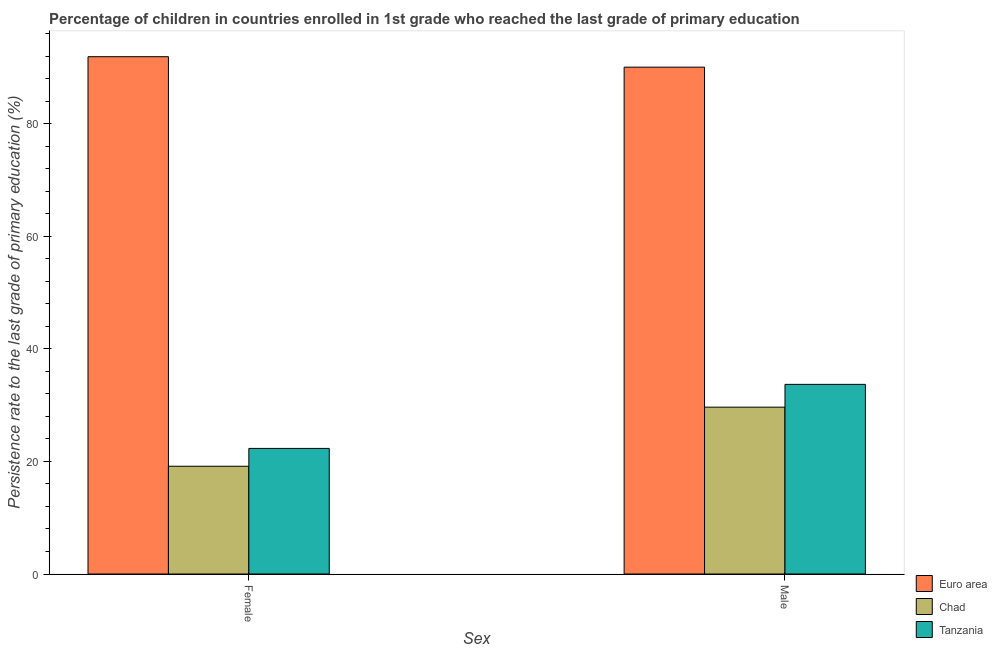How many different coloured bars are there?
Provide a succinct answer. 3. How many groups of bars are there?
Provide a short and direct response. 2. Are the number of bars per tick equal to the number of legend labels?
Offer a very short reply. Yes. Are the number of bars on each tick of the X-axis equal?
Give a very brief answer. Yes. How many bars are there on the 2nd tick from the left?
Offer a very short reply. 3. What is the label of the 1st group of bars from the left?
Ensure brevity in your answer.  Female. What is the persistence rate of female students in Chad?
Provide a short and direct response. 19.15. Across all countries, what is the maximum persistence rate of male students?
Your answer should be compact. 90.04. Across all countries, what is the minimum persistence rate of female students?
Your response must be concise. 19.15. In which country was the persistence rate of male students minimum?
Keep it short and to the point. Chad. What is the total persistence rate of female students in the graph?
Your response must be concise. 133.36. What is the difference between the persistence rate of female students in Chad and that in Euro area?
Your answer should be very brief. -72.76. What is the difference between the persistence rate of female students in Euro area and the persistence rate of male students in Tanzania?
Keep it short and to the point. 58.21. What is the average persistence rate of male students per country?
Your answer should be very brief. 51.12. What is the difference between the persistence rate of female students and persistence rate of male students in Chad?
Give a very brief answer. -10.49. In how many countries, is the persistence rate of male students greater than 44 %?
Provide a succinct answer. 1. What is the ratio of the persistence rate of female students in Euro area to that in Chad?
Your response must be concise. 4.8. What does the 2nd bar from the left in Female represents?
Make the answer very short. Chad. What does the 1st bar from the right in Female represents?
Provide a succinct answer. Tanzania. How many bars are there?
Ensure brevity in your answer.  6. Are all the bars in the graph horizontal?
Your answer should be very brief. No. How many countries are there in the graph?
Provide a succinct answer. 3. Does the graph contain any zero values?
Offer a very short reply. No. Does the graph contain grids?
Provide a succinct answer. No. How are the legend labels stacked?
Keep it short and to the point. Vertical. What is the title of the graph?
Offer a terse response. Percentage of children in countries enrolled in 1st grade who reached the last grade of primary education. Does "Latin America(all income levels)" appear as one of the legend labels in the graph?
Your answer should be very brief. No. What is the label or title of the X-axis?
Provide a succinct answer. Sex. What is the label or title of the Y-axis?
Your answer should be very brief. Persistence rate to the last grade of primary education (%). What is the Persistence rate to the last grade of primary education (%) in Euro area in Female?
Your response must be concise. 91.9. What is the Persistence rate to the last grade of primary education (%) of Chad in Female?
Make the answer very short. 19.15. What is the Persistence rate to the last grade of primary education (%) in Tanzania in Female?
Provide a short and direct response. 22.31. What is the Persistence rate to the last grade of primary education (%) in Euro area in Male?
Offer a terse response. 90.04. What is the Persistence rate to the last grade of primary education (%) in Chad in Male?
Make the answer very short. 29.64. What is the Persistence rate to the last grade of primary education (%) in Tanzania in Male?
Your answer should be compact. 33.69. Across all Sex, what is the maximum Persistence rate to the last grade of primary education (%) of Euro area?
Make the answer very short. 91.9. Across all Sex, what is the maximum Persistence rate to the last grade of primary education (%) in Chad?
Ensure brevity in your answer.  29.64. Across all Sex, what is the maximum Persistence rate to the last grade of primary education (%) of Tanzania?
Give a very brief answer. 33.69. Across all Sex, what is the minimum Persistence rate to the last grade of primary education (%) in Euro area?
Keep it short and to the point. 90.04. Across all Sex, what is the minimum Persistence rate to the last grade of primary education (%) of Chad?
Your answer should be compact. 19.15. Across all Sex, what is the minimum Persistence rate to the last grade of primary education (%) in Tanzania?
Offer a terse response. 22.31. What is the total Persistence rate to the last grade of primary education (%) of Euro area in the graph?
Provide a succinct answer. 181.94. What is the total Persistence rate to the last grade of primary education (%) in Chad in the graph?
Your answer should be very brief. 48.78. What is the total Persistence rate to the last grade of primary education (%) of Tanzania in the graph?
Offer a very short reply. 56. What is the difference between the Persistence rate to the last grade of primary education (%) in Euro area in Female and that in Male?
Make the answer very short. 1.86. What is the difference between the Persistence rate to the last grade of primary education (%) of Chad in Female and that in Male?
Your answer should be very brief. -10.49. What is the difference between the Persistence rate to the last grade of primary education (%) of Tanzania in Female and that in Male?
Keep it short and to the point. -11.38. What is the difference between the Persistence rate to the last grade of primary education (%) of Euro area in Female and the Persistence rate to the last grade of primary education (%) of Chad in Male?
Give a very brief answer. 62.26. What is the difference between the Persistence rate to the last grade of primary education (%) of Euro area in Female and the Persistence rate to the last grade of primary education (%) of Tanzania in Male?
Your answer should be very brief. 58.21. What is the difference between the Persistence rate to the last grade of primary education (%) of Chad in Female and the Persistence rate to the last grade of primary education (%) of Tanzania in Male?
Ensure brevity in your answer.  -14.54. What is the average Persistence rate to the last grade of primary education (%) of Euro area per Sex?
Your answer should be compact. 90.97. What is the average Persistence rate to the last grade of primary education (%) in Chad per Sex?
Your answer should be very brief. 24.39. What is the average Persistence rate to the last grade of primary education (%) of Tanzania per Sex?
Make the answer very short. 28. What is the difference between the Persistence rate to the last grade of primary education (%) of Euro area and Persistence rate to the last grade of primary education (%) of Chad in Female?
Provide a succinct answer. 72.76. What is the difference between the Persistence rate to the last grade of primary education (%) in Euro area and Persistence rate to the last grade of primary education (%) in Tanzania in Female?
Provide a short and direct response. 69.59. What is the difference between the Persistence rate to the last grade of primary education (%) of Chad and Persistence rate to the last grade of primary education (%) of Tanzania in Female?
Your answer should be very brief. -3.17. What is the difference between the Persistence rate to the last grade of primary education (%) of Euro area and Persistence rate to the last grade of primary education (%) of Chad in Male?
Make the answer very short. 60.4. What is the difference between the Persistence rate to the last grade of primary education (%) of Euro area and Persistence rate to the last grade of primary education (%) of Tanzania in Male?
Keep it short and to the point. 56.35. What is the difference between the Persistence rate to the last grade of primary education (%) of Chad and Persistence rate to the last grade of primary education (%) of Tanzania in Male?
Keep it short and to the point. -4.05. What is the ratio of the Persistence rate to the last grade of primary education (%) in Euro area in Female to that in Male?
Your answer should be very brief. 1.02. What is the ratio of the Persistence rate to the last grade of primary education (%) of Chad in Female to that in Male?
Ensure brevity in your answer.  0.65. What is the ratio of the Persistence rate to the last grade of primary education (%) of Tanzania in Female to that in Male?
Provide a short and direct response. 0.66. What is the difference between the highest and the second highest Persistence rate to the last grade of primary education (%) in Euro area?
Ensure brevity in your answer.  1.86. What is the difference between the highest and the second highest Persistence rate to the last grade of primary education (%) of Chad?
Provide a succinct answer. 10.49. What is the difference between the highest and the second highest Persistence rate to the last grade of primary education (%) of Tanzania?
Give a very brief answer. 11.38. What is the difference between the highest and the lowest Persistence rate to the last grade of primary education (%) in Euro area?
Your answer should be very brief. 1.86. What is the difference between the highest and the lowest Persistence rate to the last grade of primary education (%) of Chad?
Your response must be concise. 10.49. What is the difference between the highest and the lowest Persistence rate to the last grade of primary education (%) of Tanzania?
Provide a short and direct response. 11.38. 